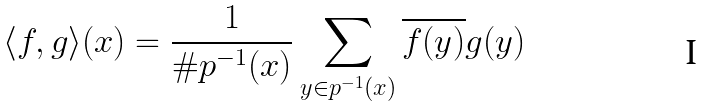Convert formula to latex. <formula><loc_0><loc_0><loc_500><loc_500>\langle f , g \rangle ( x ) = \frac { 1 } { \# p ^ { - 1 } ( x ) } \sum _ { y \in p ^ { - 1 } ( x ) } \overline { f ( y ) } g ( y )</formula> 